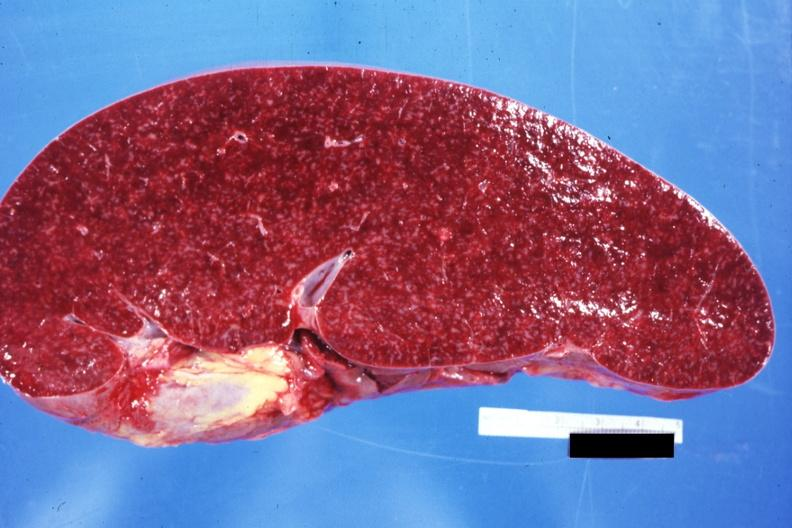does this image show cut surface prominent lymph follicles size appears normal see other sides this case?
Answer the question using a single word or phrase. Yes 